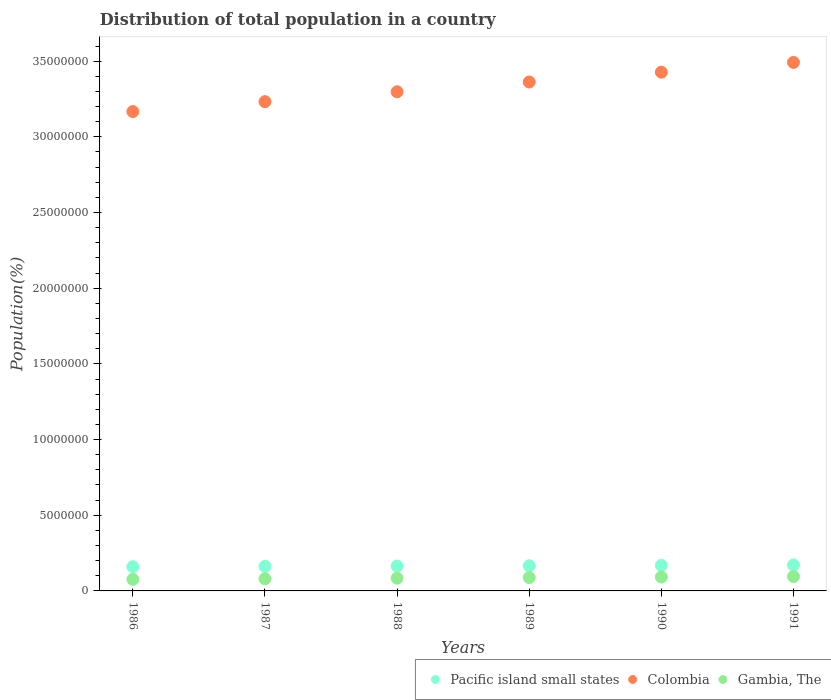Is the number of dotlines equal to the number of legend labels?
Keep it short and to the point. Yes. What is the population of in Colombia in 1988?
Give a very brief answer. 3.30e+07. Across all years, what is the maximum population of in Gambia, The?
Your response must be concise. 9.49e+05. Across all years, what is the minimum population of in Pacific island small states?
Provide a short and direct response. 1.60e+06. In which year was the population of in Pacific island small states minimum?
Offer a terse response. 1986. What is the total population of in Colombia in the graph?
Your answer should be very brief. 2.00e+08. What is the difference between the population of in Pacific island small states in 1989 and that in 1991?
Keep it short and to the point. -4.97e+04. What is the difference between the population of in Pacific island small states in 1991 and the population of in Gambia, The in 1990?
Offer a very short reply. 7.95e+05. What is the average population of in Gambia, The per year?
Keep it short and to the point. 8.60e+05. In the year 1986, what is the difference between the population of in Gambia, The and population of in Colombia?
Give a very brief answer. -3.09e+07. In how many years, is the population of in Colombia greater than 9000000 %?
Offer a very short reply. 6. What is the ratio of the population of in Gambia, The in 1986 to that in 1987?
Offer a very short reply. 0.95. Is the population of in Gambia, The in 1986 less than that in 1988?
Keep it short and to the point. Yes. What is the difference between the highest and the second highest population of in Gambia, The?
Give a very brief answer. 3.27e+04. What is the difference between the highest and the lowest population of in Pacific island small states?
Your answer should be compact. 1.10e+05. Is the sum of the population of in Colombia in 1988 and 1989 greater than the maximum population of in Pacific island small states across all years?
Offer a terse response. Yes. Does the population of in Pacific island small states monotonically increase over the years?
Give a very brief answer. Yes. Is the population of in Colombia strictly greater than the population of in Pacific island small states over the years?
Your answer should be compact. Yes. How many dotlines are there?
Ensure brevity in your answer.  3. What is the difference between two consecutive major ticks on the Y-axis?
Your answer should be compact. 5.00e+06. Are the values on the major ticks of Y-axis written in scientific E-notation?
Your answer should be very brief. No. Does the graph contain any zero values?
Give a very brief answer. No. Where does the legend appear in the graph?
Offer a terse response. Bottom right. What is the title of the graph?
Provide a succinct answer. Distribution of total population in a country. Does "Panama" appear as one of the legend labels in the graph?
Give a very brief answer. No. What is the label or title of the X-axis?
Offer a very short reply. Years. What is the label or title of the Y-axis?
Make the answer very short. Population(%). What is the Population(%) in Pacific island small states in 1986?
Ensure brevity in your answer.  1.60e+06. What is the Population(%) in Colombia in 1986?
Offer a terse response. 3.17e+07. What is the Population(%) in Gambia, The in 1986?
Ensure brevity in your answer.  7.67e+05. What is the Population(%) in Pacific island small states in 1987?
Your response must be concise. 1.62e+06. What is the Population(%) of Colombia in 1987?
Your response must be concise. 3.23e+07. What is the Population(%) of Gambia, The in 1987?
Keep it short and to the point. 8.04e+05. What is the Population(%) of Pacific island small states in 1988?
Offer a terse response. 1.64e+06. What is the Population(%) of Colombia in 1988?
Give a very brief answer. 3.30e+07. What is the Population(%) in Gambia, The in 1988?
Ensure brevity in your answer.  8.43e+05. What is the Population(%) of Pacific island small states in 1989?
Your answer should be compact. 1.66e+06. What is the Population(%) in Colombia in 1989?
Provide a short and direct response. 3.36e+07. What is the Population(%) of Gambia, The in 1989?
Give a very brief answer. 8.81e+05. What is the Population(%) in Pacific island small states in 1990?
Offer a terse response. 1.69e+06. What is the Population(%) in Colombia in 1990?
Make the answer very short. 3.43e+07. What is the Population(%) in Gambia, The in 1990?
Give a very brief answer. 9.17e+05. What is the Population(%) in Pacific island small states in 1991?
Make the answer very short. 1.71e+06. What is the Population(%) in Colombia in 1991?
Your answer should be very brief. 3.49e+07. What is the Population(%) of Gambia, The in 1991?
Your answer should be very brief. 9.49e+05. Across all years, what is the maximum Population(%) of Pacific island small states?
Give a very brief answer. 1.71e+06. Across all years, what is the maximum Population(%) in Colombia?
Offer a very short reply. 3.49e+07. Across all years, what is the maximum Population(%) in Gambia, The?
Provide a succinct answer. 9.49e+05. Across all years, what is the minimum Population(%) in Pacific island small states?
Your response must be concise. 1.60e+06. Across all years, what is the minimum Population(%) in Colombia?
Your answer should be very brief. 3.17e+07. Across all years, what is the minimum Population(%) of Gambia, The?
Provide a succinct answer. 7.67e+05. What is the total Population(%) in Pacific island small states in the graph?
Give a very brief answer. 9.93e+06. What is the total Population(%) of Colombia in the graph?
Offer a very short reply. 2.00e+08. What is the total Population(%) in Gambia, The in the graph?
Your response must be concise. 5.16e+06. What is the difference between the Population(%) in Pacific island small states in 1986 and that in 1987?
Offer a terse response. -2.11e+04. What is the difference between the Population(%) of Colombia in 1986 and that in 1987?
Provide a short and direct response. -6.55e+05. What is the difference between the Population(%) of Gambia, The in 1986 and that in 1987?
Provide a succinct answer. -3.75e+04. What is the difference between the Population(%) of Pacific island small states in 1986 and that in 1988?
Provide a short and direct response. -4.03e+04. What is the difference between the Population(%) in Colombia in 1986 and that in 1988?
Offer a very short reply. -1.31e+06. What is the difference between the Population(%) of Gambia, The in 1986 and that in 1988?
Offer a very short reply. -7.65e+04. What is the difference between the Population(%) in Pacific island small states in 1986 and that in 1989?
Make the answer very short. -6.06e+04. What is the difference between the Population(%) in Colombia in 1986 and that in 1989?
Offer a very short reply. -1.95e+06. What is the difference between the Population(%) of Gambia, The in 1986 and that in 1989?
Give a very brief answer. -1.15e+05. What is the difference between the Population(%) of Pacific island small states in 1986 and that in 1990?
Ensure brevity in your answer.  -8.37e+04. What is the difference between the Population(%) of Colombia in 1986 and that in 1990?
Give a very brief answer. -2.60e+06. What is the difference between the Population(%) in Gambia, The in 1986 and that in 1990?
Offer a very short reply. -1.50e+05. What is the difference between the Population(%) of Pacific island small states in 1986 and that in 1991?
Your answer should be compact. -1.10e+05. What is the difference between the Population(%) in Colombia in 1986 and that in 1991?
Give a very brief answer. -3.25e+06. What is the difference between the Population(%) of Gambia, The in 1986 and that in 1991?
Ensure brevity in your answer.  -1.83e+05. What is the difference between the Population(%) of Pacific island small states in 1987 and that in 1988?
Make the answer very short. -1.93e+04. What is the difference between the Population(%) of Colombia in 1987 and that in 1988?
Offer a terse response. -6.51e+05. What is the difference between the Population(%) of Gambia, The in 1987 and that in 1988?
Give a very brief answer. -3.89e+04. What is the difference between the Population(%) in Pacific island small states in 1987 and that in 1989?
Offer a terse response. -3.95e+04. What is the difference between the Population(%) of Colombia in 1987 and that in 1989?
Offer a terse response. -1.30e+06. What is the difference between the Population(%) in Gambia, The in 1987 and that in 1989?
Give a very brief answer. -7.70e+04. What is the difference between the Population(%) in Pacific island small states in 1987 and that in 1990?
Provide a short and direct response. -6.26e+04. What is the difference between the Population(%) in Colombia in 1987 and that in 1990?
Offer a terse response. -1.95e+06. What is the difference between the Population(%) of Gambia, The in 1987 and that in 1990?
Your answer should be very brief. -1.13e+05. What is the difference between the Population(%) in Pacific island small states in 1987 and that in 1991?
Make the answer very short. -8.93e+04. What is the difference between the Population(%) of Colombia in 1987 and that in 1991?
Provide a succinct answer. -2.59e+06. What is the difference between the Population(%) of Gambia, The in 1987 and that in 1991?
Your answer should be compact. -1.45e+05. What is the difference between the Population(%) of Pacific island small states in 1988 and that in 1989?
Give a very brief answer. -2.02e+04. What is the difference between the Population(%) in Colombia in 1988 and that in 1989?
Your response must be concise. -6.49e+05. What is the difference between the Population(%) in Gambia, The in 1988 and that in 1989?
Keep it short and to the point. -3.81e+04. What is the difference between the Population(%) of Pacific island small states in 1988 and that in 1990?
Make the answer very short. -4.33e+04. What is the difference between the Population(%) in Colombia in 1988 and that in 1990?
Ensure brevity in your answer.  -1.30e+06. What is the difference between the Population(%) in Gambia, The in 1988 and that in 1990?
Your response must be concise. -7.38e+04. What is the difference between the Population(%) of Pacific island small states in 1988 and that in 1991?
Provide a short and direct response. -7.00e+04. What is the difference between the Population(%) in Colombia in 1988 and that in 1991?
Provide a succinct answer. -1.94e+06. What is the difference between the Population(%) of Gambia, The in 1988 and that in 1991?
Provide a short and direct response. -1.06e+05. What is the difference between the Population(%) of Pacific island small states in 1989 and that in 1990?
Make the answer very short. -2.31e+04. What is the difference between the Population(%) in Colombia in 1989 and that in 1990?
Your answer should be very brief. -6.47e+05. What is the difference between the Population(%) of Gambia, The in 1989 and that in 1990?
Offer a very short reply. -3.57e+04. What is the difference between the Population(%) of Pacific island small states in 1989 and that in 1991?
Your answer should be very brief. -4.97e+04. What is the difference between the Population(%) of Colombia in 1989 and that in 1991?
Your answer should be compact. -1.29e+06. What is the difference between the Population(%) of Gambia, The in 1989 and that in 1991?
Your answer should be compact. -6.83e+04. What is the difference between the Population(%) of Pacific island small states in 1990 and that in 1991?
Your answer should be compact. -2.66e+04. What is the difference between the Population(%) of Colombia in 1990 and that in 1991?
Offer a very short reply. -6.45e+05. What is the difference between the Population(%) of Gambia, The in 1990 and that in 1991?
Offer a very short reply. -3.27e+04. What is the difference between the Population(%) of Pacific island small states in 1986 and the Population(%) of Colombia in 1987?
Your answer should be very brief. -3.07e+07. What is the difference between the Population(%) of Pacific island small states in 1986 and the Population(%) of Gambia, The in 1987?
Give a very brief answer. 7.97e+05. What is the difference between the Population(%) in Colombia in 1986 and the Population(%) in Gambia, The in 1987?
Give a very brief answer. 3.09e+07. What is the difference between the Population(%) in Pacific island small states in 1986 and the Population(%) in Colombia in 1988?
Make the answer very short. -3.14e+07. What is the difference between the Population(%) in Pacific island small states in 1986 and the Population(%) in Gambia, The in 1988?
Give a very brief answer. 7.59e+05. What is the difference between the Population(%) of Colombia in 1986 and the Population(%) of Gambia, The in 1988?
Your response must be concise. 3.08e+07. What is the difference between the Population(%) in Pacific island small states in 1986 and the Population(%) in Colombia in 1989?
Make the answer very short. -3.20e+07. What is the difference between the Population(%) in Pacific island small states in 1986 and the Population(%) in Gambia, The in 1989?
Make the answer very short. 7.20e+05. What is the difference between the Population(%) in Colombia in 1986 and the Population(%) in Gambia, The in 1989?
Provide a short and direct response. 3.08e+07. What is the difference between the Population(%) in Pacific island small states in 1986 and the Population(%) in Colombia in 1990?
Provide a short and direct response. -3.27e+07. What is the difference between the Population(%) in Pacific island small states in 1986 and the Population(%) in Gambia, The in 1990?
Your answer should be compact. 6.85e+05. What is the difference between the Population(%) of Colombia in 1986 and the Population(%) of Gambia, The in 1990?
Your answer should be compact. 3.08e+07. What is the difference between the Population(%) of Pacific island small states in 1986 and the Population(%) of Colombia in 1991?
Your response must be concise. -3.33e+07. What is the difference between the Population(%) in Pacific island small states in 1986 and the Population(%) in Gambia, The in 1991?
Ensure brevity in your answer.  6.52e+05. What is the difference between the Population(%) of Colombia in 1986 and the Population(%) of Gambia, The in 1991?
Offer a terse response. 3.07e+07. What is the difference between the Population(%) in Pacific island small states in 1987 and the Population(%) in Colombia in 1988?
Give a very brief answer. -3.14e+07. What is the difference between the Population(%) of Pacific island small states in 1987 and the Population(%) of Gambia, The in 1988?
Provide a short and direct response. 7.80e+05. What is the difference between the Population(%) in Colombia in 1987 and the Population(%) in Gambia, The in 1988?
Your response must be concise. 3.15e+07. What is the difference between the Population(%) of Pacific island small states in 1987 and the Population(%) of Colombia in 1989?
Keep it short and to the point. -3.20e+07. What is the difference between the Population(%) of Pacific island small states in 1987 and the Population(%) of Gambia, The in 1989?
Provide a short and direct response. 7.41e+05. What is the difference between the Population(%) in Colombia in 1987 and the Population(%) in Gambia, The in 1989?
Your response must be concise. 3.14e+07. What is the difference between the Population(%) in Pacific island small states in 1987 and the Population(%) in Colombia in 1990?
Give a very brief answer. -3.26e+07. What is the difference between the Population(%) of Pacific island small states in 1987 and the Population(%) of Gambia, The in 1990?
Offer a terse response. 7.06e+05. What is the difference between the Population(%) of Colombia in 1987 and the Population(%) of Gambia, The in 1990?
Give a very brief answer. 3.14e+07. What is the difference between the Population(%) of Pacific island small states in 1987 and the Population(%) of Colombia in 1991?
Provide a succinct answer. -3.33e+07. What is the difference between the Population(%) in Pacific island small states in 1987 and the Population(%) in Gambia, The in 1991?
Your response must be concise. 6.73e+05. What is the difference between the Population(%) in Colombia in 1987 and the Population(%) in Gambia, The in 1991?
Ensure brevity in your answer.  3.14e+07. What is the difference between the Population(%) of Pacific island small states in 1988 and the Population(%) of Colombia in 1989?
Offer a very short reply. -3.20e+07. What is the difference between the Population(%) in Pacific island small states in 1988 and the Population(%) in Gambia, The in 1989?
Your answer should be compact. 7.61e+05. What is the difference between the Population(%) of Colombia in 1988 and the Population(%) of Gambia, The in 1989?
Provide a succinct answer. 3.21e+07. What is the difference between the Population(%) in Pacific island small states in 1988 and the Population(%) in Colombia in 1990?
Offer a terse response. -3.26e+07. What is the difference between the Population(%) in Pacific island small states in 1988 and the Population(%) in Gambia, The in 1990?
Your answer should be compact. 7.25e+05. What is the difference between the Population(%) in Colombia in 1988 and the Population(%) in Gambia, The in 1990?
Your answer should be compact. 3.21e+07. What is the difference between the Population(%) of Pacific island small states in 1988 and the Population(%) of Colombia in 1991?
Your answer should be compact. -3.33e+07. What is the difference between the Population(%) in Pacific island small states in 1988 and the Population(%) in Gambia, The in 1991?
Keep it short and to the point. 6.92e+05. What is the difference between the Population(%) in Colombia in 1988 and the Population(%) in Gambia, The in 1991?
Ensure brevity in your answer.  3.20e+07. What is the difference between the Population(%) in Pacific island small states in 1989 and the Population(%) in Colombia in 1990?
Give a very brief answer. -3.26e+07. What is the difference between the Population(%) of Pacific island small states in 1989 and the Population(%) of Gambia, The in 1990?
Offer a very short reply. 7.45e+05. What is the difference between the Population(%) of Colombia in 1989 and the Population(%) of Gambia, The in 1990?
Provide a short and direct response. 3.27e+07. What is the difference between the Population(%) in Pacific island small states in 1989 and the Population(%) in Colombia in 1991?
Keep it short and to the point. -3.33e+07. What is the difference between the Population(%) of Pacific island small states in 1989 and the Population(%) of Gambia, The in 1991?
Keep it short and to the point. 7.13e+05. What is the difference between the Population(%) of Colombia in 1989 and the Population(%) of Gambia, The in 1991?
Your answer should be compact. 3.27e+07. What is the difference between the Population(%) of Pacific island small states in 1990 and the Population(%) of Colombia in 1991?
Your answer should be very brief. -3.32e+07. What is the difference between the Population(%) of Pacific island small states in 1990 and the Population(%) of Gambia, The in 1991?
Ensure brevity in your answer.  7.36e+05. What is the difference between the Population(%) in Colombia in 1990 and the Population(%) in Gambia, The in 1991?
Your response must be concise. 3.33e+07. What is the average Population(%) of Pacific island small states per year?
Provide a short and direct response. 1.65e+06. What is the average Population(%) in Colombia per year?
Your answer should be compact. 3.33e+07. What is the average Population(%) of Gambia, The per year?
Your answer should be compact. 8.60e+05. In the year 1986, what is the difference between the Population(%) of Pacific island small states and Population(%) of Colombia?
Your answer should be compact. -3.01e+07. In the year 1986, what is the difference between the Population(%) of Pacific island small states and Population(%) of Gambia, The?
Keep it short and to the point. 8.35e+05. In the year 1986, what is the difference between the Population(%) of Colombia and Population(%) of Gambia, The?
Make the answer very short. 3.09e+07. In the year 1987, what is the difference between the Population(%) in Pacific island small states and Population(%) in Colombia?
Provide a short and direct response. -3.07e+07. In the year 1987, what is the difference between the Population(%) of Pacific island small states and Population(%) of Gambia, The?
Your answer should be very brief. 8.18e+05. In the year 1987, what is the difference between the Population(%) in Colombia and Population(%) in Gambia, The?
Provide a short and direct response. 3.15e+07. In the year 1988, what is the difference between the Population(%) of Pacific island small states and Population(%) of Colombia?
Ensure brevity in your answer.  -3.13e+07. In the year 1988, what is the difference between the Population(%) of Pacific island small states and Population(%) of Gambia, The?
Your response must be concise. 7.99e+05. In the year 1988, what is the difference between the Population(%) in Colombia and Population(%) in Gambia, The?
Provide a short and direct response. 3.21e+07. In the year 1989, what is the difference between the Population(%) of Pacific island small states and Population(%) of Colombia?
Ensure brevity in your answer.  -3.20e+07. In the year 1989, what is the difference between the Population(%) in Pacific island small states and Population(%) in Gambia, The?
Your answer should be very brief. 7.81e+05. In the year 1989, what is the difference between the Population(%) of Colombia and Population(%) of Gambia, The?
Give a very brief answer. 3.27e+07. In the year 1990, what is the difference between the Population(%) in Pacific island small states and Population(%) in Colombia?
Keep it short and to the point. -3.26e+07. In the year 1990, what is the difference between the Population(%) in Pacific island small states and Population(%) in Gambia, The?
Your response must be concise. 7.68e+05. In the year 1990, what is the difference between the Population(%) of Colombia and Population(%) of Gambia, The?
Give a very brief answer. 3.34e+07. In the year 1991, what is the difference between the Population(%) of Pacific island small states and Population(%) of Colombia?
Your answer should be very brief. -3.32e+07. In the year 1991, what is the difference between the Population(%) of Pacific island small states and Population(%) of Gambia, The?
Your answer should be very brief. 7.62e+05. In the year 1991, what is the difference between the Population(%) of Colombia and Population(%) of Gambia, The?
Keep it short and to the point. 3.40e+07. What is the ratio of the Population(%) of Colombia in 1986 to that in 1987?
Offer a very short reply. 0.98. What is the ratio of the Population(%) of Gambia, The in 1986 to that in 1987?
Your answer should be very brief. 0.95. What is the ratio of the Population(%) in Pacific island small states in 1986 to that in 1988?
Offer a very short reply. 0.98. What is the ratio of the Population(%) in Colombia in 1986 to that in 1988?
Your response must be concise. 0.96. What is the ratio of the Population(%) of Gambia, The in 1986 to that in 1988?
Offer a very short reply. 0.91. What is the ratio of the Population(%) of Pacific island small states in 1986 to that in 1989?
Keep it short and to the point. 0.96. What is the ratio of the Population(%) in Colombia in 1986 to that in 1989?
Make the answer very short. 0.94. What is the ratio of the Population(%) of Gambia, The in 1986 to that in 1989?
Ensure brevity in your answer.  0.87. What is the ratio of the Population(%) of Pacific island small states in 1986 to that in 1990?
Offer a terse response. 0.95. What is the ratio of the Population(%) of Colombia in 1986 to that in 1990?
Give a very brief answer. 0.92. What is the ratio of the Population(%) in Gambia, The in 1986 to that in 1990?
Your answer should be compact. 0.84. What is the ratio of the Population(%) in Pacific island small states in 1986 to that in 1991?
Your answer should be compact. 0.94. What is the ratio of the Population(%) of Colombia in 1986 to that in 1991?
Keep it short and to the point. 0.91. What is the ratio of the Population(%) of Gambia, The in 1986 to that in 1991?
Offer a terse response. 0.81. What is the ratio of the Population(%) in Pacific island small states in 1987 to that in 1988?
Keep it short and to the point. 0.99. What is the ratio of the Population(%) of Colombia in 1987 to that in 1988?
Your response must be concise. 0.98. What is the ratio of the Population(%) of Gambia, The in 1987 to that in 1988?
Keep it short and to the point. 0.95. What is the ratio of the Population(%) of Pacific island small states in 1987 to that in 1989?
Ensure brevity in your answer.  0.98. What is the ratio of the Population(%) of Colombia in 1987 to that in 1989?
Give a very brief answer. 0.96. What is the ratio of the Population(%) in Gambia, The in 1987 to that in 1989?
Offer a very short reply. 0.91. What is the ratio of the Population(%) in Pacific island small states in 1987 to that in 1990?
Ensure brevity in your answer.  0.96. What is the ratio of the Population(%) of Colombia in 1987 to that in 1990?
Provide a short and direct response. 0.94. What is the ratio of the Population(%) of Gambia, The in 1987 to that in 1990?
Provide a short and direct response. 0.88. What is the ratio of the Population(%) of Pacific island small states in 1987 to that in 1991?
Offer a terse response. 0.95. What is the ratio of the Population(%) in Colombia in 1987 to that in 1991?
Give a very brief answer. 0.93. What is the ratio of the Population(%) in Gambia, The in 1987 to that in 1991?
Your answer should be very brief. 0.85. What is the ratio of the Population(%) in Pacific island small states in 1988 to that in 1989?
Offer a terse response. 0.99. What is the ratio of the Population(%) of Colombia in 1988 to that in 1989?
Keep it short and to the point. 0.98. What is the ratio of the Population(%) of Gambia, The in 1988 to that in 1989?
Your response must be concise. 0.96. What is the ratio of the Population(%) in Pacific island small states in 1988 to that in 1990?
Keep it short and to the point. 0.97. What is the ratio of the Population(%) of Colombia in 1988 to that in 1990?
Provide a short and direct response. 0.96. What is the ratio of the Population(%) in Gambia, The in 1988 to that in 1990?
Provide a succinct answer. 0.92. What is the ratio of the Population(%) in Pacific island small states in 1988 to that in 1991?
Keep it short and to the point. 0.96. What is the ratio of the Population(%) in Gambia, The in 1988 to that in 1991?
Provide a succinct answer. 0.89. What is the ratio of the Population(%) of Pacific island small states in 1989 to that in 1990?
Give a very brief answer. 0.99. What is the ratio of the Population(%) of Colombia in 1989 to that in 1990?
Your answer should be very brief. 0.98. What is the ratio of the Population(%) of Gambia, The in 1989 to that in 1990?
Provide a short and direct response. 0.96. What is the ratio of the Population(%) in Pacific island small states in 1989 to that in 1991?
Offer a very short reply. 0.97. What is the ratio of the Population(%) in Gambia, The in 1989 to that in 1991?
Ensure brevity in your answer.  0.93. What is the ratio of the Population(%) of Pacific island small states in 1990 to that in 1991?
Make the answer very short. 0.98. What is the ratio of the Population(%) of Colombia in 1990 to that in 1991?
Keep it short and to the point. 0.98. What is the ratio of the Population(%) of Gambia, The in 1990 to that in 1991?
Provide a succinct answer. 0.97. What is the difference between the highest and the second highest Population(%) of Pacific island small states?
Your answer should be very brief. 2.66e+04. What is the difference between the highest and the second highest Population(%) of Colombia?
Ensure brevity in your answer.  6.45e+05. What is the difference between the highest and the second highest Population(%) of Gambia, The?
Ensure brevity in your answer.  3.27e+04. What is the difference between the highest and the lowest Population(%) in Pacific island small states?
Provide a succinct answer. 1.10e+05. What is the difference between the highest and the lowest Population(%) in Colombia?
Give a very brief answer. 3.25e+06. What is the difference between the highest and the lowest Population(%) in Gambia, The?
Your answer should be compact. 1.83e+05. 